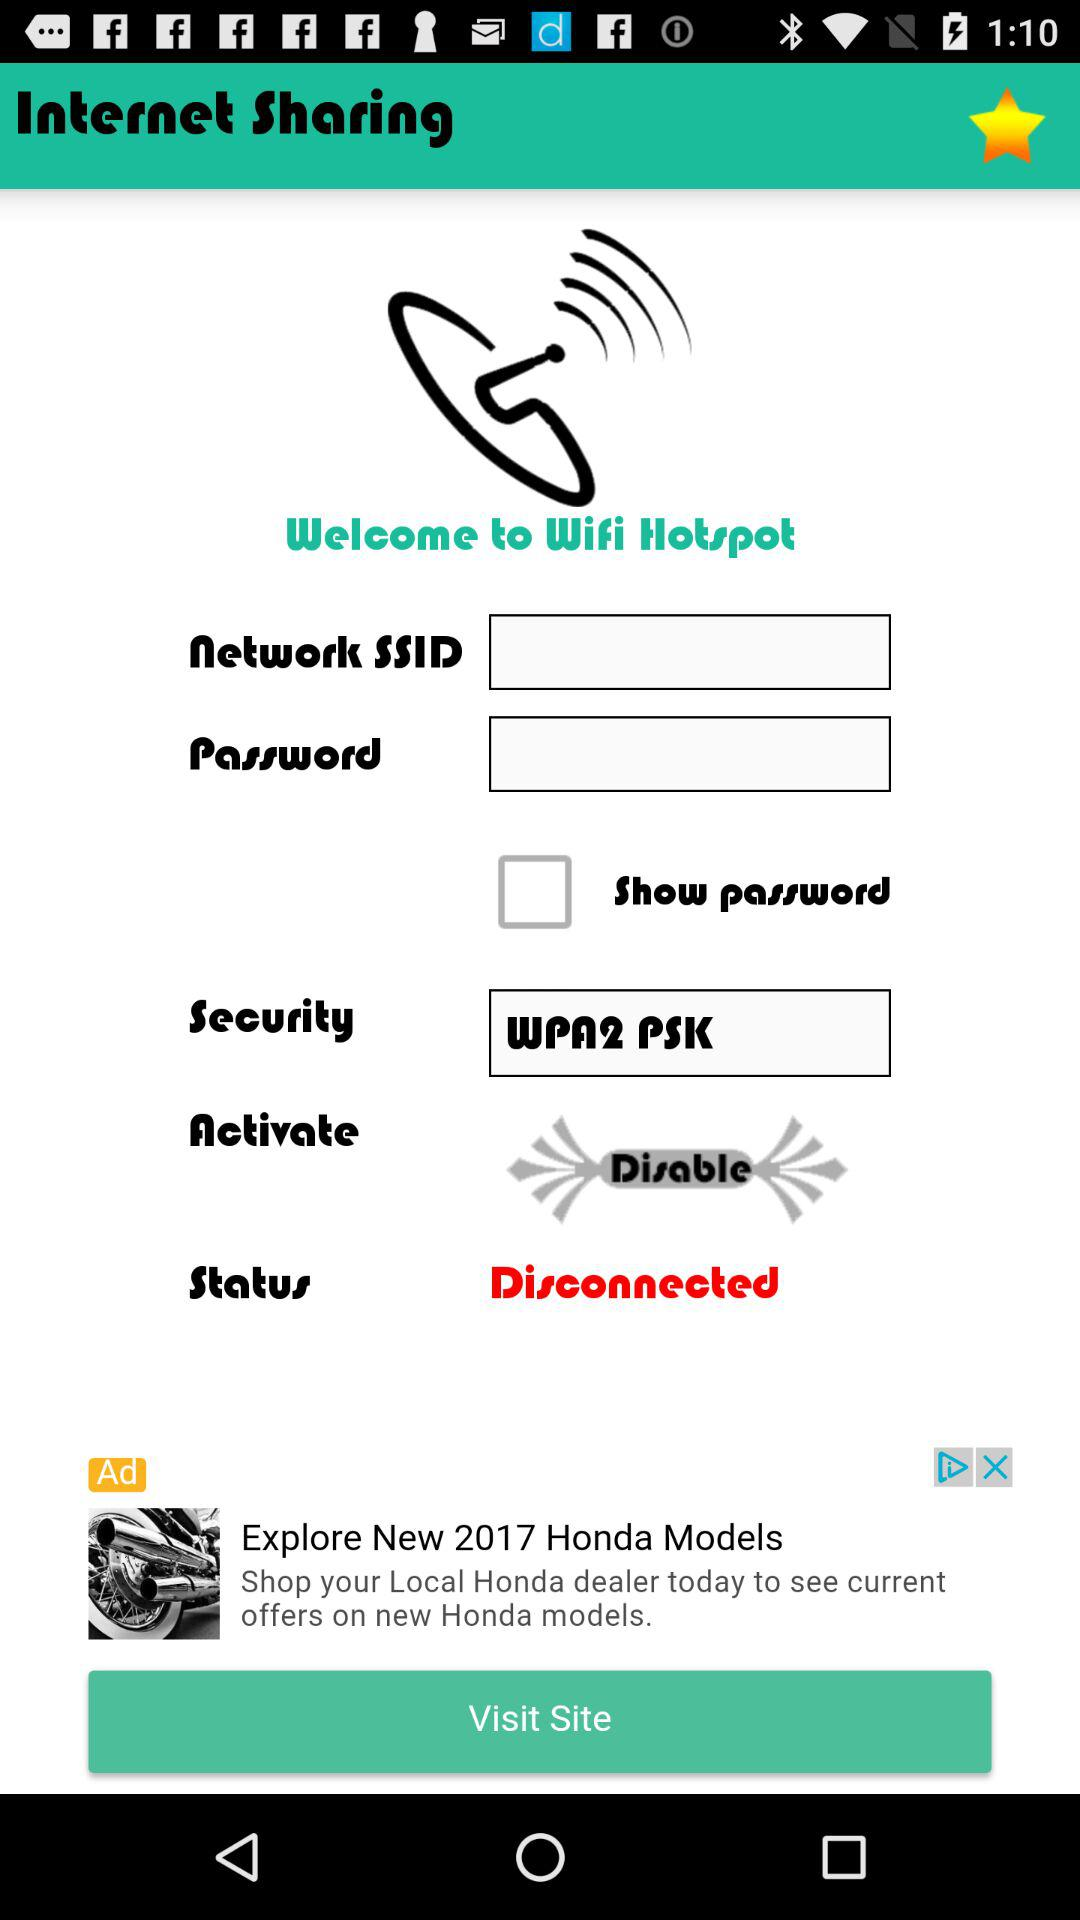What is the status? The status is "Disconnected". 